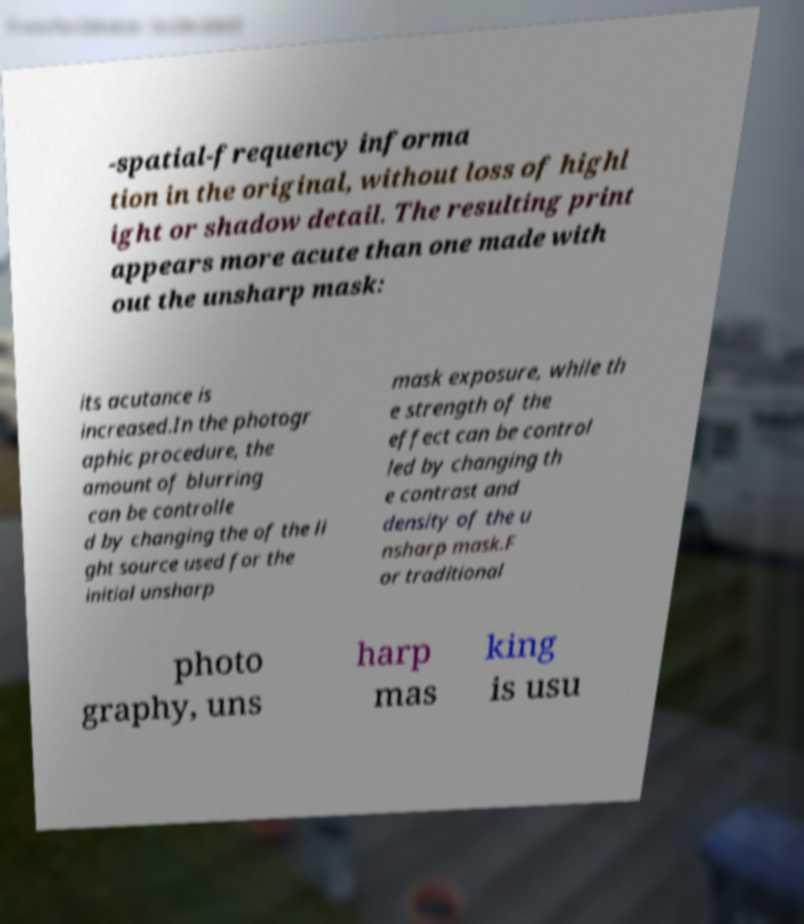Could you extract and type out the text from this image? -spatial-frequency informa tion in the original, without loss of highl ight or shadow detail. The resulting print appears more acute than one made with out the unsharp mask: its acutance is increased.In the photogr aphic procedure, the amount of blurring can be controlle d by changing the of the li ght source used for the initial unsharp mask exposure, while th e strength of the effect can be control led by changing th e contrast and density of the u nsharp mask.F or traditional photo graphy, uns harp mas king is usu 